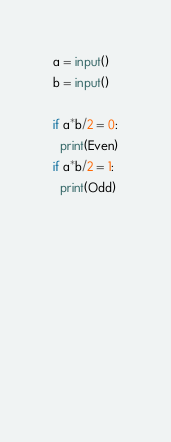<code> <loc_0><loc_0><loc_500><loc_500><_Python_>a = input()
b = input()

if a*b/2 = 0:
  print(Even)
if a*b/2 = 1:
  print(Odd)
  

  
  
  
  
  
  
  </code> 